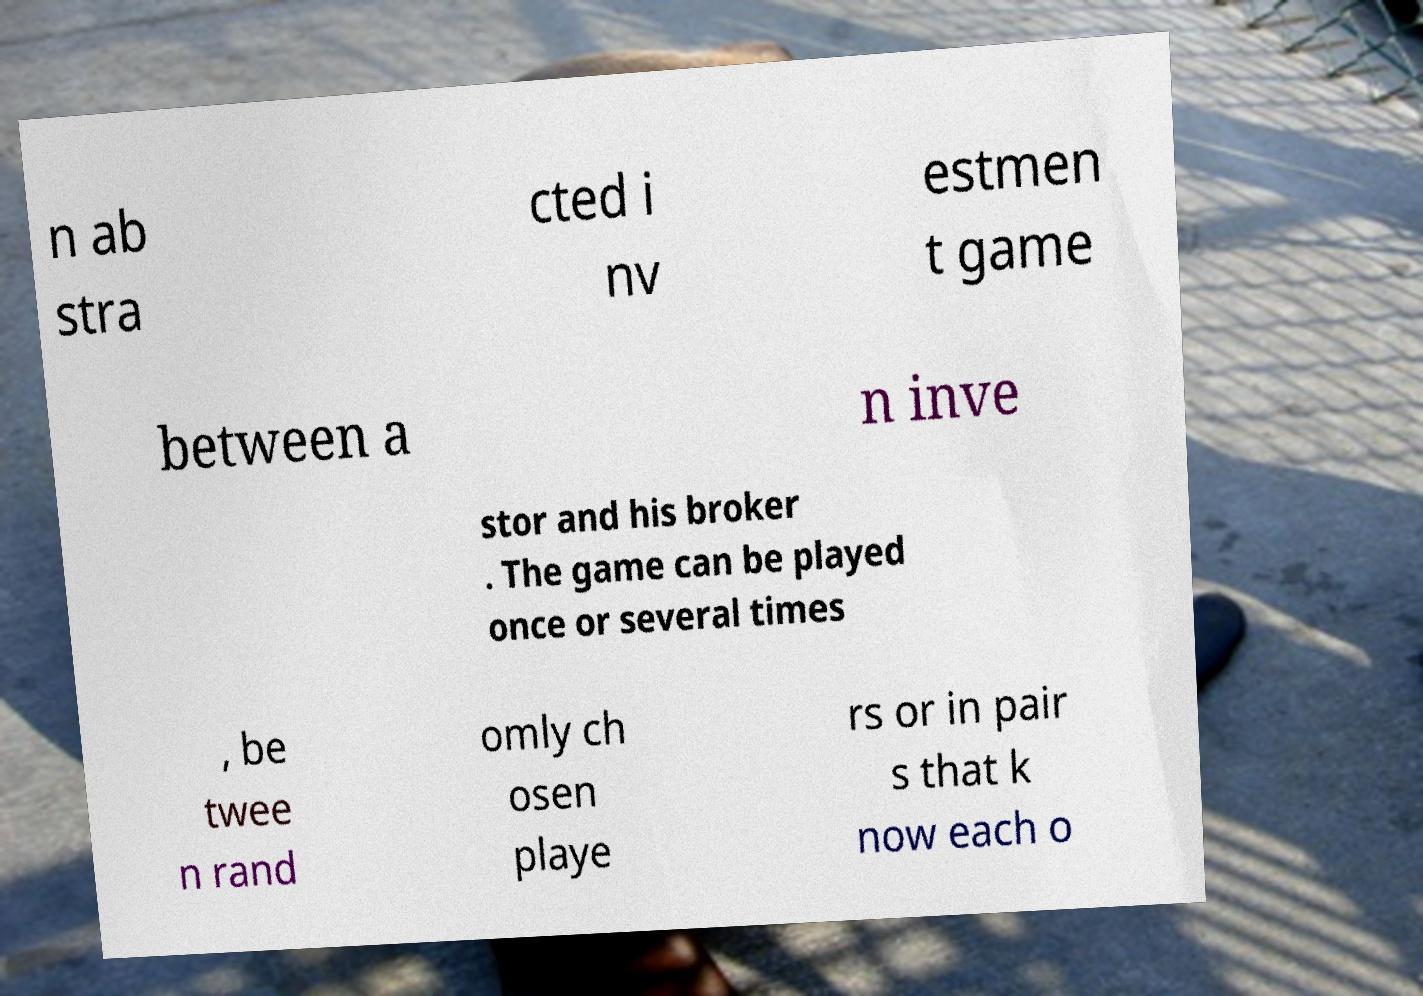What messages or text are displayed in this image? I need them in a readable, typed format. n ab stra cted i nv estmen t game between a n inve stor and his broker . The game can be played once or several times , be twee n rand omly ch osen playe rs or in pair s that k now each o 